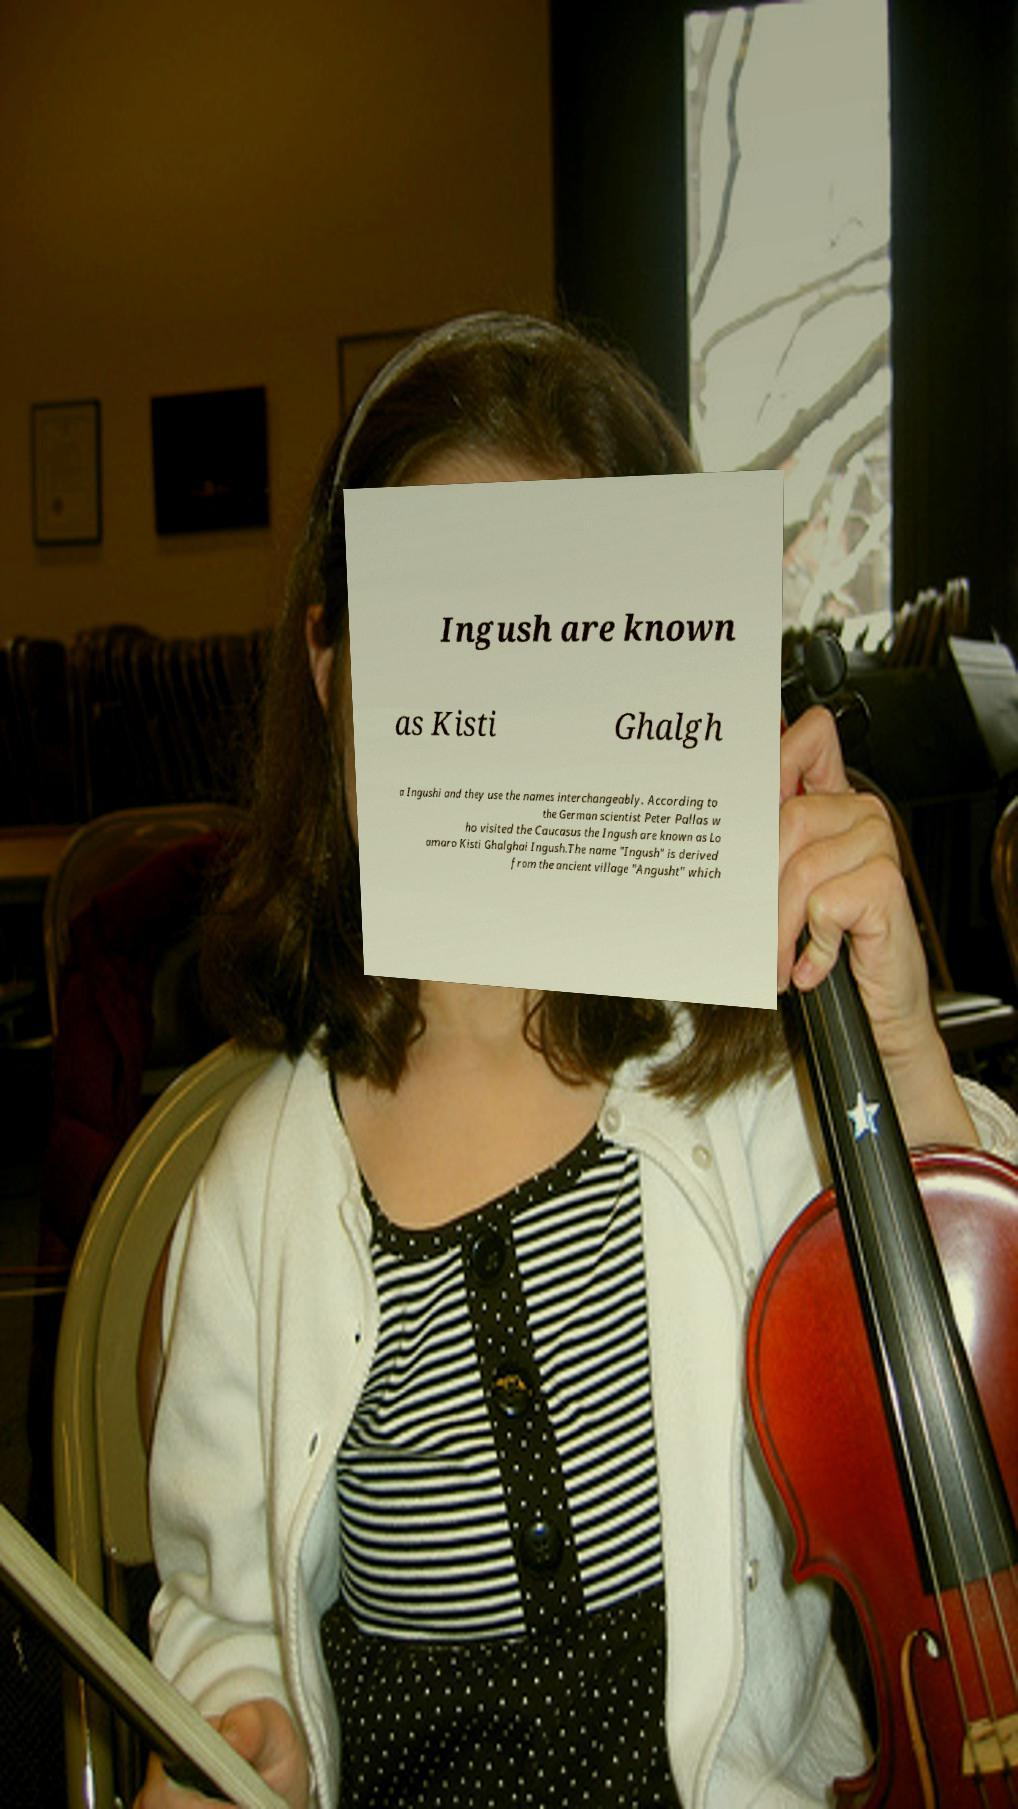There's text embedded in this image that I need extracted. Can you transcribe it verbatim? Ingush are known as Kisti Ghalgh a Ingushi and they use the names interchangeably. According to the German scientist Peter Pallas w ho visited the Caucasus the Ingush are known as Lo amaro Kisti Ghalghai Ingush.The name "Ingush" is derived from the ancient village "Angusht" which 